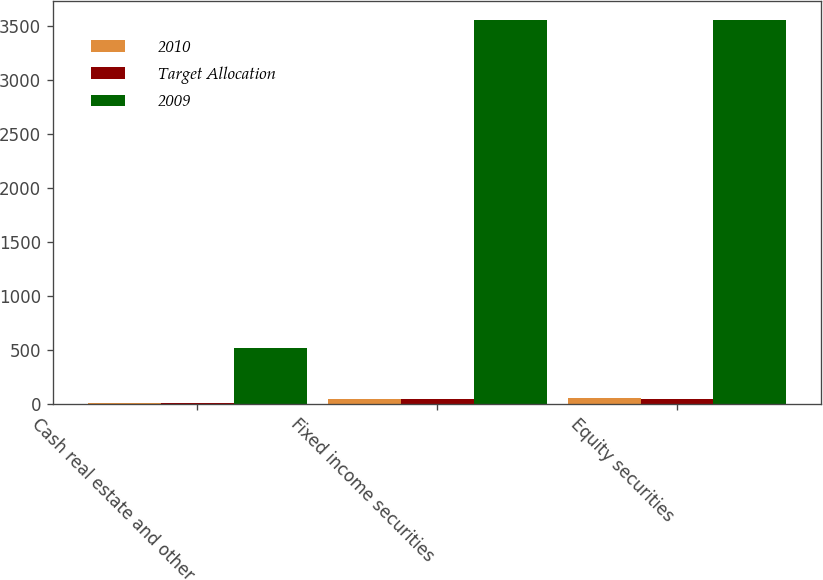<chart> <loc_0><loc_0><loc_500><loc_500><stacked_bar_chart><ecel><fcel>Cash real estate and other<fcel>Fixed income securities<fcel>Equity securities<nl><fcel>2010<fcel>11<fcel>40<fcel>49<nl><fcel>Target Allocation<fcel>9<fcel>45<fcel>46<nl><fcel>2009<fcel>515<fcel>3555<fcel>3555<nl></chart> 